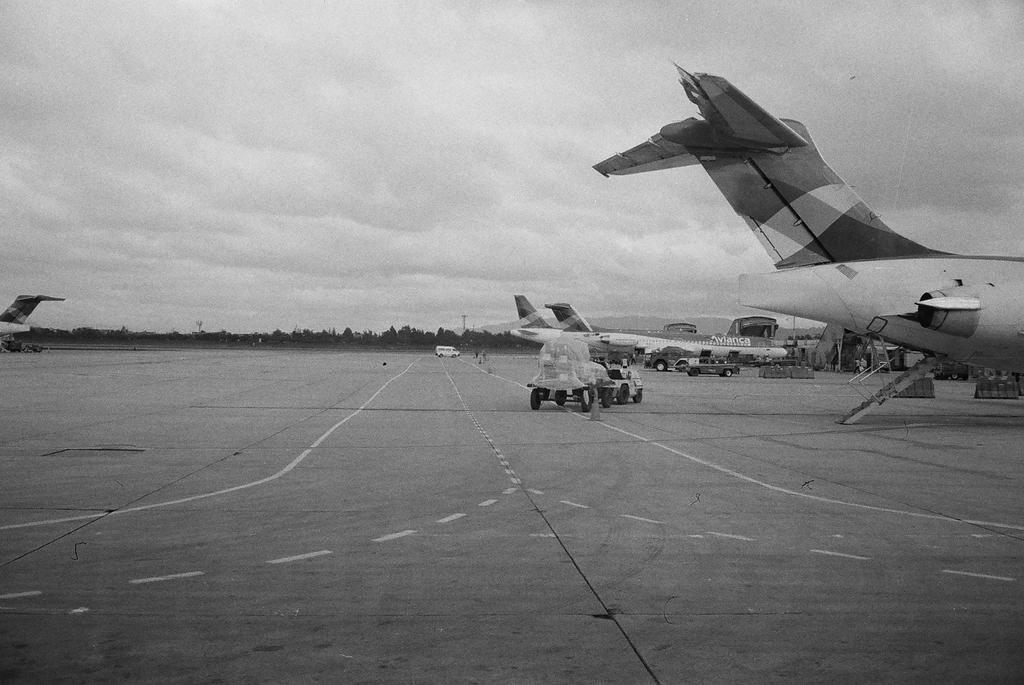What is the main subject of the image? The main subject of the image is airplanes. What else can be seen on the ground in the image? There are vehicles on the ground in the image. Can you describe the objects in the image? There are objects in the image, but their specific nature is not mentioned in the facts. What is visible in the background of the image? Trees and the sky are visible in the background of the image. What can be seen in the sky? Clouds are present in the sky. What type of lamp is hanging from the goat's neck in the image? There is no lamp or goat present in the image; it features airplanes and vehicles on the ground. 